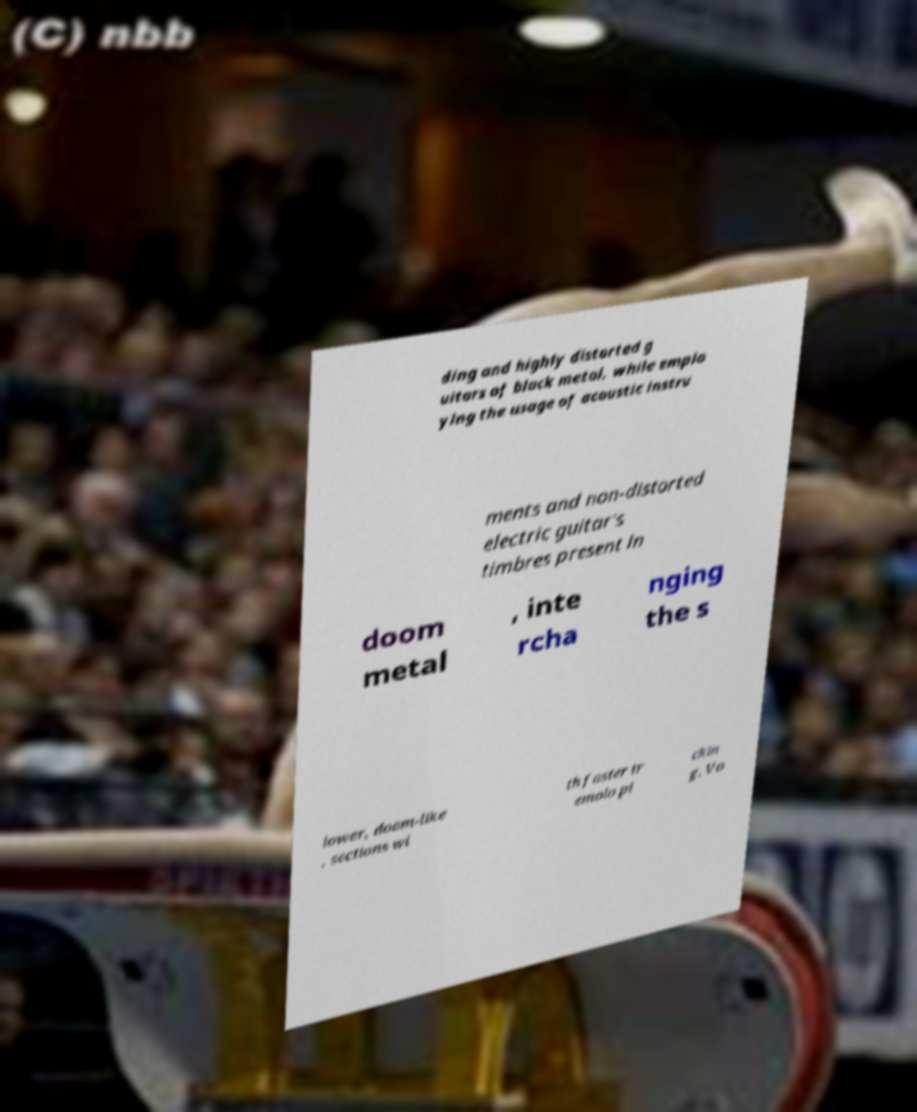Can you read and provide the text displayed in the image?This photo seems to have some interesting text. Can you extract and type it out for me? ding and highly distorted g uitars of black metal, while emplo ying the usage of acoustic instru ments and non-distorted electric guitar's timbres present in doom metal , inte rcha nging the s lower, doom-like , sections wi th faster tr emolo pi ckin g. Vo 